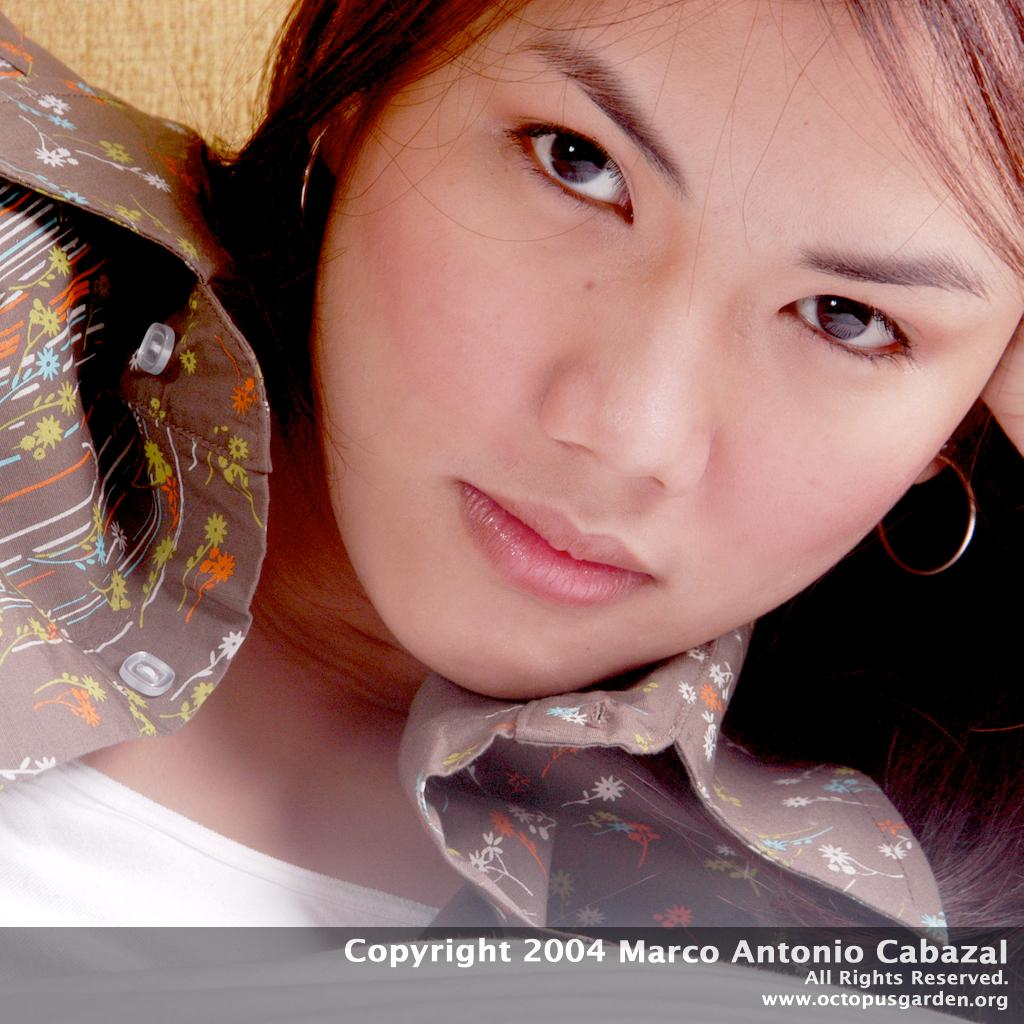What is the main subject of the image? The main subject of the image is a woman's face. What accessories is the woman wearing in the image? The woman is wearing earrings in the image. Can you describe the shirt the woman is wearing? The woman is wearing a shirt with designs in the image. What type of shirt is visible underneath the shirt with designs? The woman is wearing a white T-shirt underneath the shirt with designs. What type of sun can be seen in the image? There is no sun present in the image; it features a woman's face. How does the woman transport herself in the image? The image does not show the woman transporting herself; it only shows her face. 